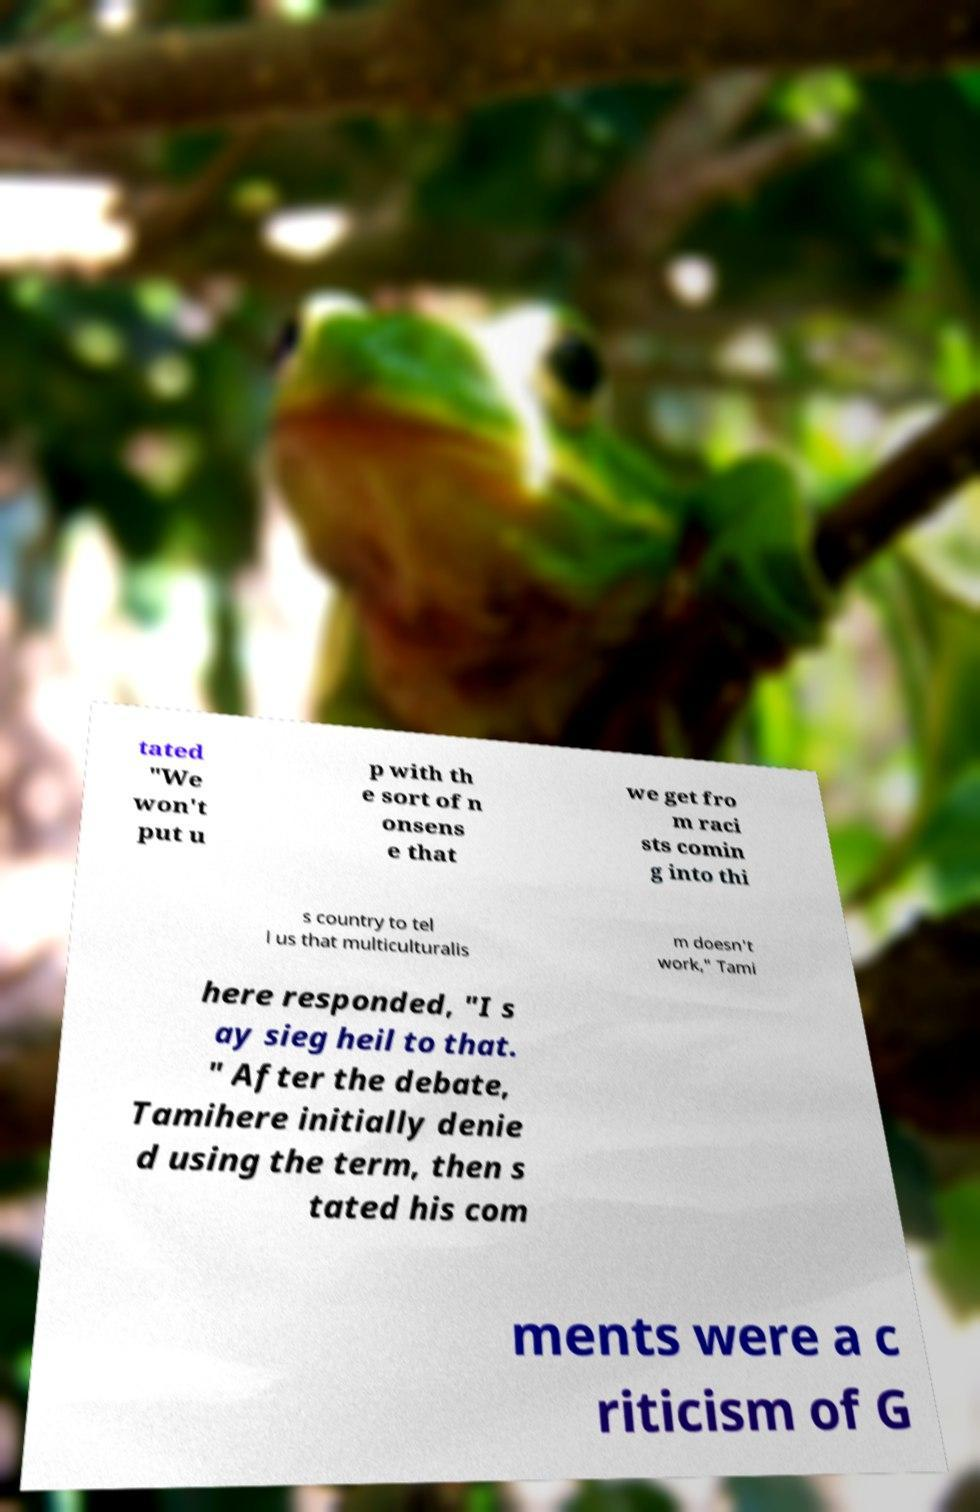For documentation purposes, I need the text within this image transcribed. Could you provide that? tated "We won't put u p with th e sort of n onsens e that we get fro m raci sts comin g into thi s country to tel l us that multiculturalis m doesn't work," Tami here responded, "I s ay sieg heil to that. " After the debate, Tamihere initially denie d using the term, then s tated his com ments were a c riticism of G 